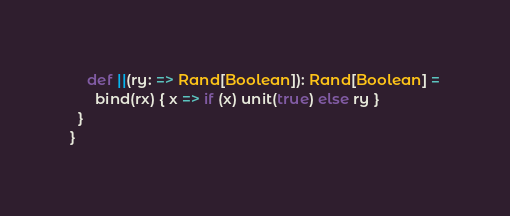<code> <loc_0><loc_0><loc_500><loc_500><_Scala_>    def ||(ry: => Rand[Boolean]): Rand[Boolean] =
      bind(rx) { x => if (x) unit(true) else ry }
  }
}
</code> 